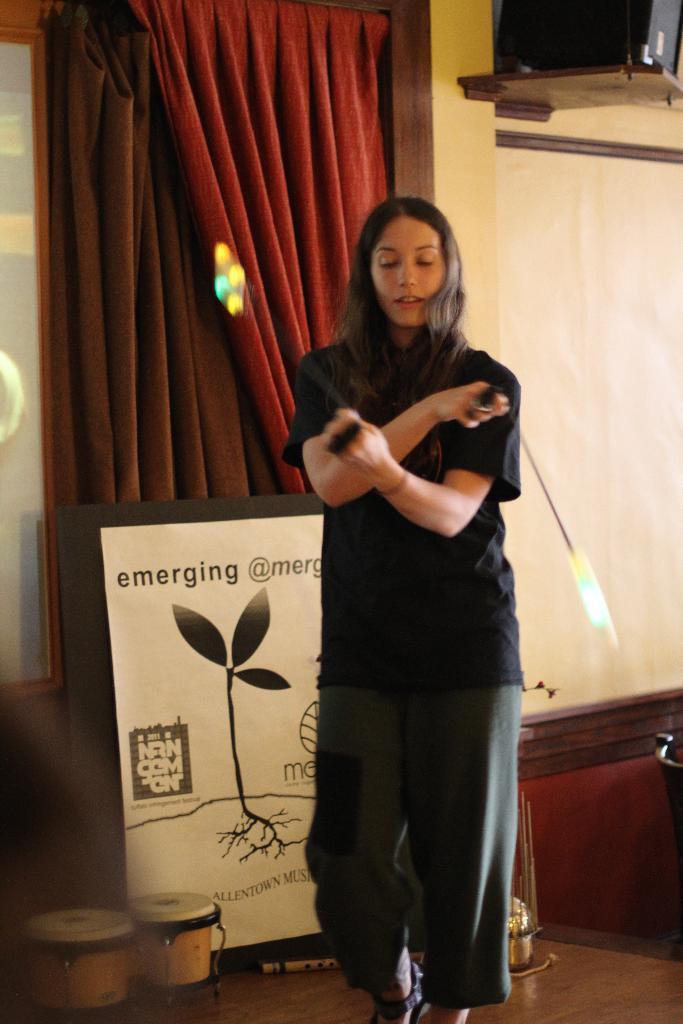In one or two sentences, can you explain what this image depicts? A person is standing wearing a black t shirt and a trouser. Behind her there are drums, banner, curtains and a speaker on the right top. 